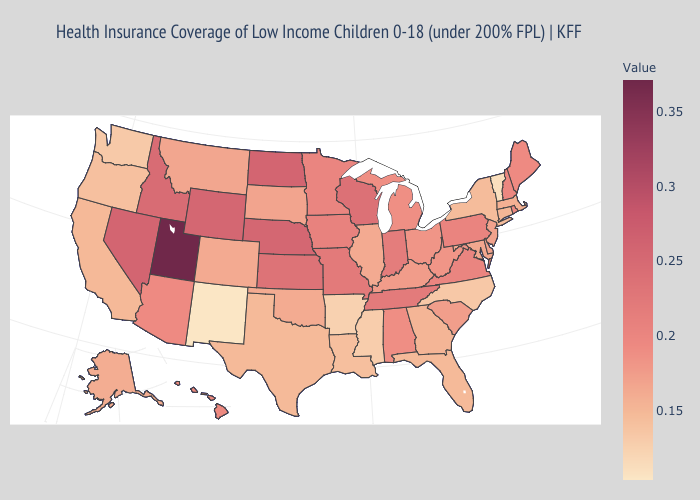Which states have the highest value in the USA?
Quick response, please. Utah. Does Utah have a lower value than Wisconsin?
Write a very short answer. No. Among the states that border Maine , which have the highest value?
Keep it brief. New Hampshire. Does Vermont have the lowest value in the Northeast?
Quick response, please. Yes. Does Alabama have the highest value in the South?
Be succinct. No. 